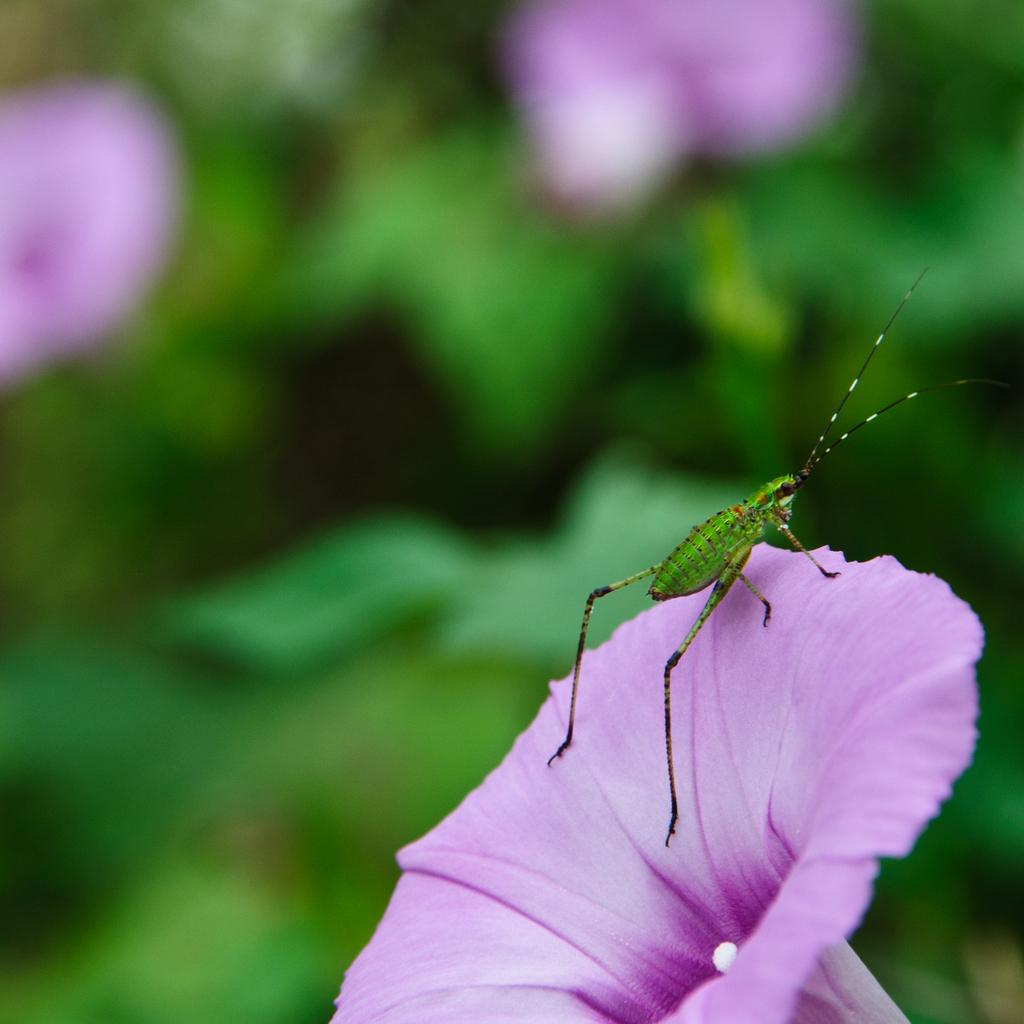What type of insect is in the image? There is a green insect in the image. Where is the green insect located? The green insect is on a lavender flower. Can you describe the background of the image? The background of the image is blurred. What is the weight of the bun in the image? There is no bun present in the image, so it is not possible to determine its weight. 